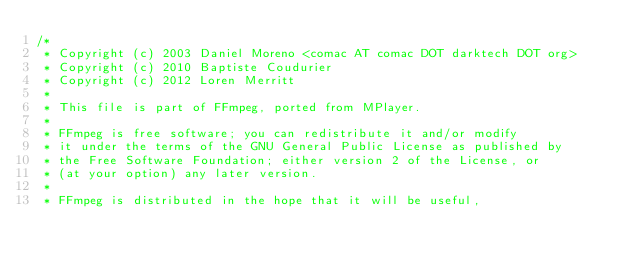Convert code to text. <code><loc_0><loc_0><loc_500><loc_500><_C_>/*
 * Copyright (c) 2003 Daniel Moreno <comac AT comac DOT darktech DOT org>
 * Copyright (c) 2010 Baptiste Coudurier
 * Copyright (c) 2012 Loren Merritt
 *
 * This file is part of FFmpeg, ported from MPlayer.
 *
 * FFmpeg is free software; you can redistribute it and/or modify
 * it under the terms of the GNU General Public License as published by
 * the Free Software Foundation; either version 2 of the License, or
 * (at your option) any later version.
 *
 * FFmpeg is distributed in the hope that it will be useful,</code> 